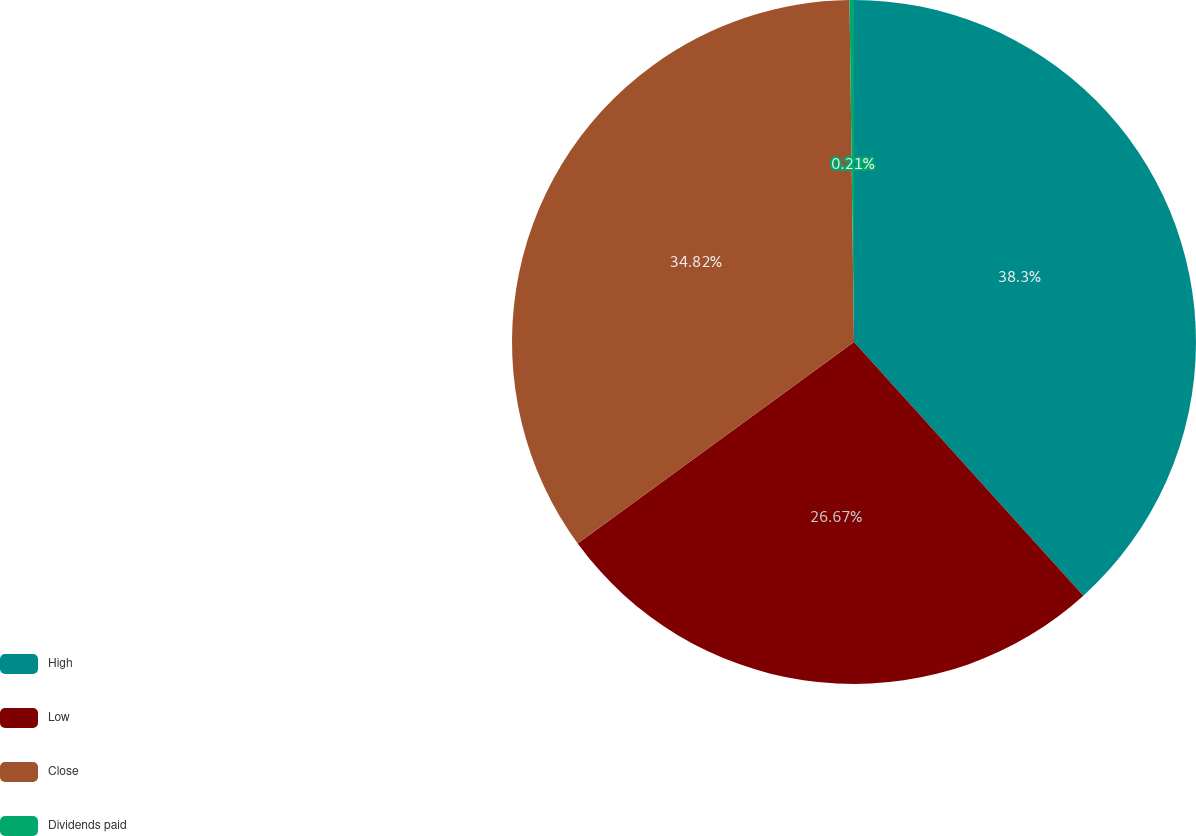<chart> <loc_0><loc_0><loc_500><loc_500><pie_chart><fcel>High<fcel>Low<fcel>Close<fcel>Dividends paid<nl><fcel>38.3%<fcel>26.67%<fcel>34.82%<fcel>0.21%<nl></chart> 